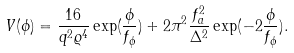Convert formula to latex. <formula><loc_0><loc_0><loc_500><loc_500>V ( \phi ) = \frac { 1 6 } { q ^ { 2 } \varrho ^ { 4 } } \exp ( \frac { \phi } { f _ { \phi } } ) + 2 \pi ^ { 2 } \frac { f _ { a } ^ { 2 } } { \Delta ^ { 2 } } \exp ( - 2 \frac { \phi } { f _ { \phi } } ) .</formula> 